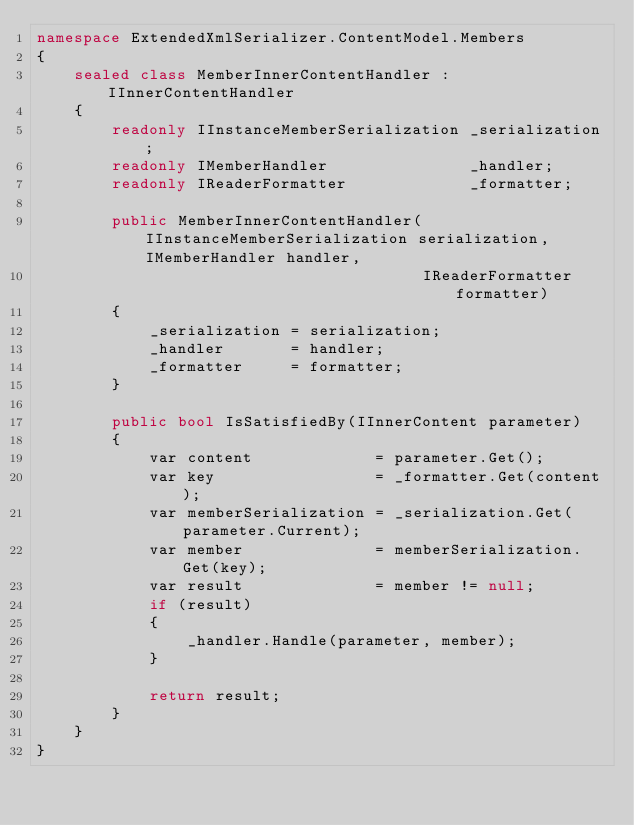<code> <loc_0><loc_0><loc_500><loc_500><_C#_>namespace ExtendedXmlSerializer.ContentModel.Members
{
	sealed class MemberInnerContentHandler : IInnerContentHandler
	{
		readonly IInstanceMemberSerialization _serialization;
		readonly IMemberHandler               _handler;
		readonly IReaderFormatter             _formatter;

		public MemberInnerContentHandler(IInstanceMemberSerialization serialization, IMemberHandler handler,
		                                 IReaderFormatter formatter)
		{
			_serialization = serialization;
			_handler       = handler;
			_formatter     = formatter;
		}

		public bool IsSatisfiedBy(IInnerContent parameter)
		{
			var content             = parameter.Get();
			var key                 = _formatter.Get(content);
			var memberSerialization = _serialization.Get(parameter.Current);
			var member              = memberSerialization.Get(key);
			var result              = member != null;
			if (result)
			{
				_handler.Handle(parameter, member);
			}

			return result;
		}
	}
}</code> 